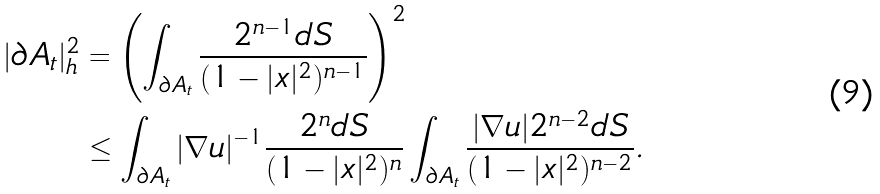Convert formula to latex. <formula><loc_0><loc_0><loc_500><loc_500>| \partial A _ { t } | _ { h } ^ { 2 } & = \left ( \int _ { \partial A _ { t } } \frac { 2 ^ { n - 1 } d S } { ( 1 - | x | ^ { 2 } ) ^ { n - 1 } } \right ) ^ { 2 } \\ & \leq \int _ { \partial A _ { t } } | \nabla u | ^ { - 1 } \frac { 2 ^ { n } d S } { ( 1 - | x | ^ { 2 } ) ^ { n } } \int _ { \partial A _ { t } } \frac { | \nabla u | 2 ^ { n - 2 } d S } { ( 1 - | x | ^ { 2 } ) ^ { n - 2 } } .</formula> 